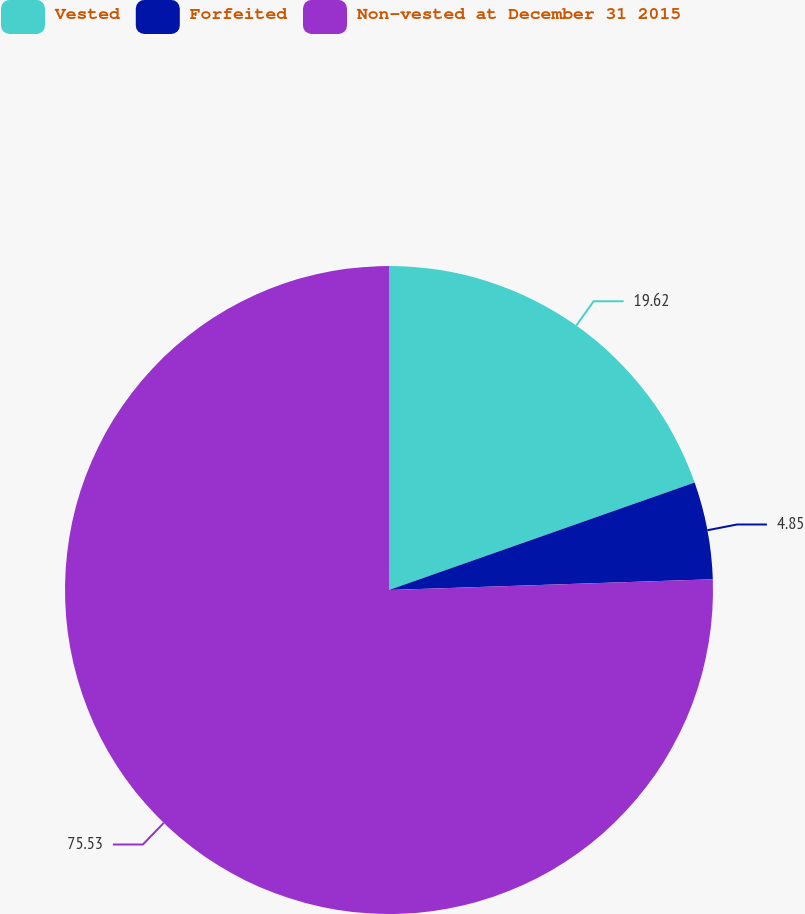<chart> <loc_0><loc_0><loc_500><loc_500><pie_chart><fcel>Vested<fcel>Forfeited<fcel>Non-vested at December 31 2015<nl><fcel>19.62%<fcel>4.85%<fcel>75.54%<nl></chart> 